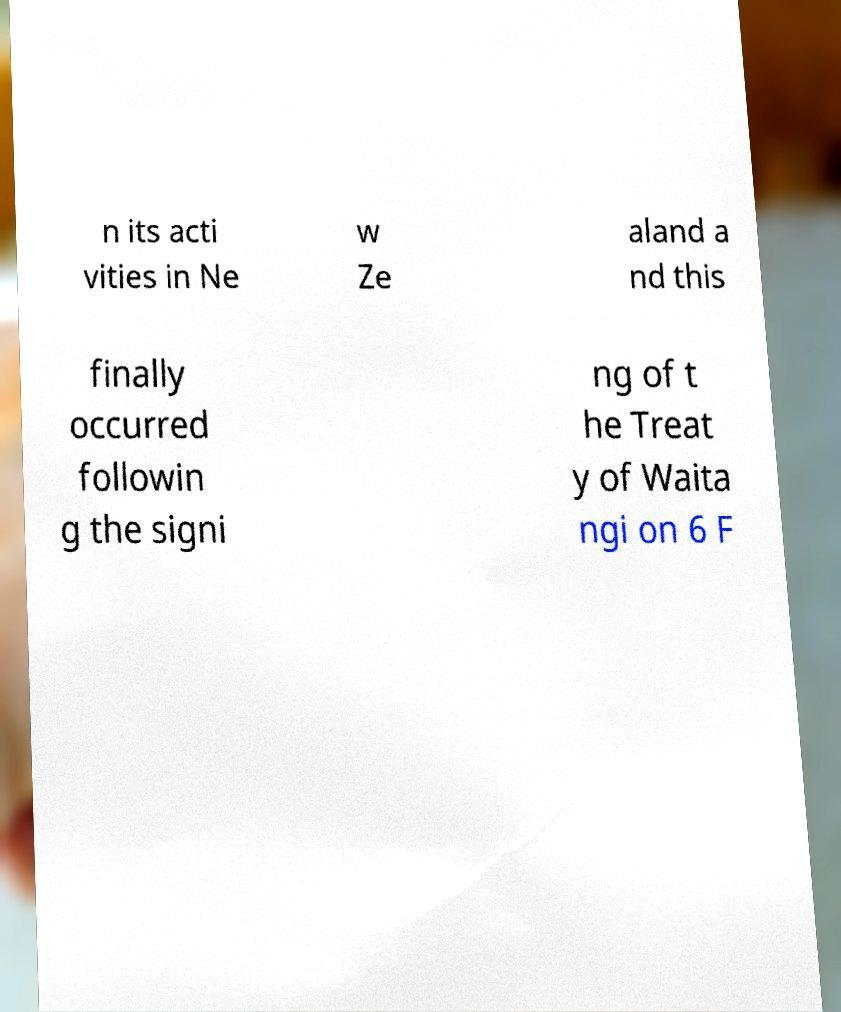Please read and relay the text visible in this image. What does it say? n its acti vities in Ne w Ze aland a nd this finally occurred followin g the signi ng of t he Treat y of Waita ngi on 6 F 